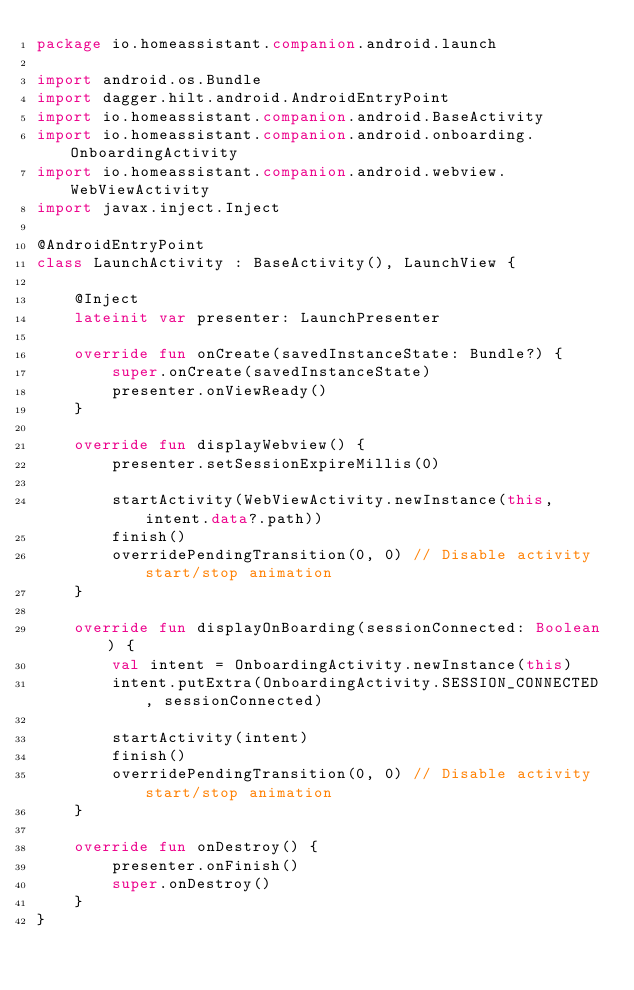<code> <loc_0><loc_0><loc_500><loc_500><_Kotlin_>package io.homeassistant.companion.android.launch

import android.os.Bundle
import dagger.hilt.android.AndroidEntryPoint
import io.homeassistant.companion.android.BaseActivity
import io.homeassistant.companion.android.onboarding.OnboardingActivity
import io.homeassistant.companion.android.webview.WebViewActivity
import javax.inject.Inject

@AndroidEntryPoint
class LaunchActivity : BaseActivity(), LaunchView {

    @Inject
    lateinit var presenter: LaunchPresenter

    override fun onCreate(savedInstanceState: Bundle?) {
        super.onCreate(savedInstanceState)
        presenter.onViewReady()
    }

    override fun displayWebview() {
        presenter.setSessionExpireMillis(0)

        startActivity(WebViewActivity.newInstance(this, intent.data?.path))
        finish()
        overridePendingTransition(0, 0) // Disable activity start/stop animation
    }

    override fun displayOnBoarding(sessionConnected: Boolean) {
        val intent = OnboardingActivity.newInstance(this)
        intent.putExtra(OnboardingActivity.SESSION_CONNECTED, sessionConnected)

        startActivity(intent)
        finish()
        overridePendingTransition(0, 0) // Disable activity start/stop animation
    }

    override fun onDestroy() {
        presenter.onFinish()
        super.onDestroy()
    }
}
</code> 